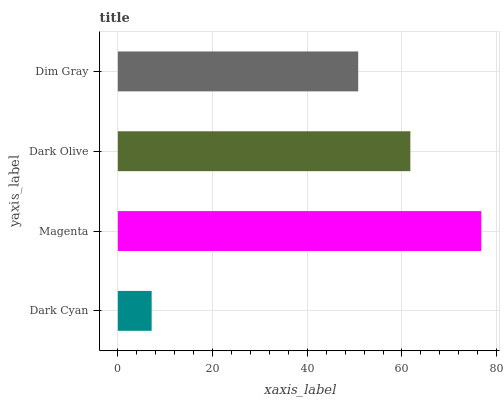Is Dark Cyan the minimum?
Answer yes or no. Yes. Is Magenta the maximum?
Answer yes or no. Yes. Is Dark Olive the minimum?
Answer yes or no. No. Is Dark Olive the maximum?
Answer yes or no. No. Is Magenta greater than Dark Olive?
Answer yes or no. Yes. Is Dark Olive less than Magenta?
Answer yes or no. Yes. Is Dark Olive greater than Magenta?
Answer yes or no. No. Is Magenta less than Dark Olive?
Answer yes or no. No. Is Dark Olive the high median?
Answer yes or no. Yes. Is Dim Gray the low median?
Answer yes or no. Yes. Is Dim Gray the high median?
Answer yes or no. No. Is Magenta the low median?
Answer yes or no. No. 